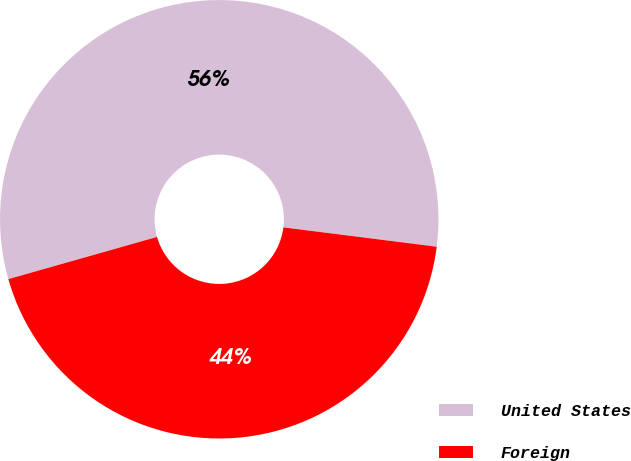Convert chart to OTSL. <chart><loc_0><loc_0><loc_500><loc_500><pie_chart><fcel>United States<fcel>Foreign<nl><fcel>56.4%<fcel>43.6%<nl></chart> 